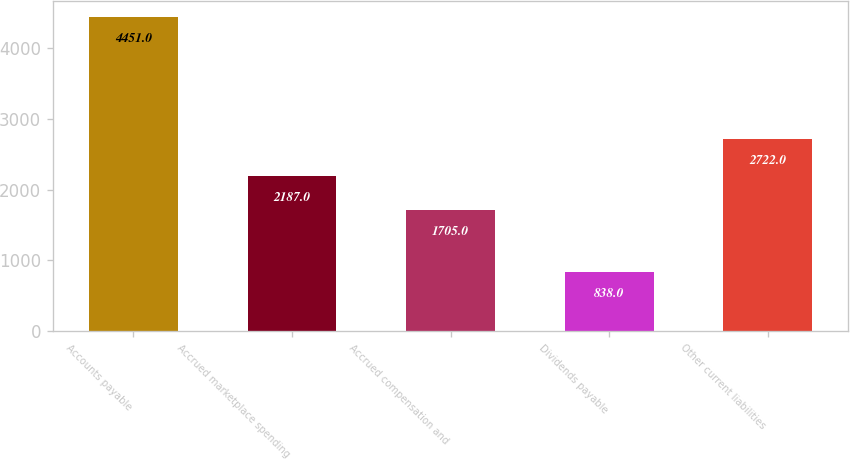Convert chart to OTSL. <chart><loc_0><loc_0><loc_500><loc_500><bar_chart><fcel>Accounts payable<fcel>Accrued marketplace spending<fcel>Accrued compensation and<fcel>Dividends payable<fcel>Other current liabilities<nl><fcel>4451<fcel>2187<fcel>1705<fcel>838<fcel>2722<nl></chart> 